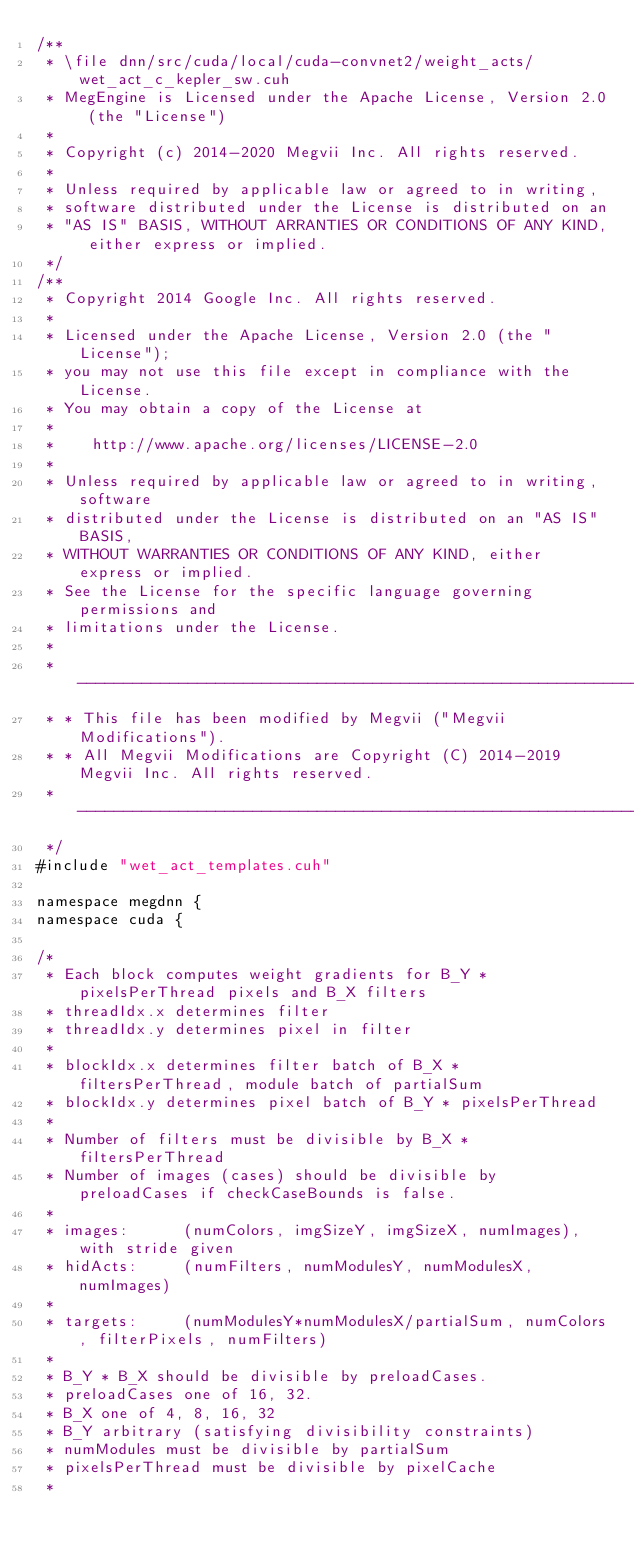Convert code to text. <code><loc_0><loc_0><loc_500><loc_500><_Cuda_>/**
 * \file dnn/src/cuda/local/cuda-convnet2/weight_acts/wet_act_c_kepler_sw.cuh
 * MegEngine is Licensed under the Apache License, Version 2.0 (the "License")
 *
 * Copyright (c) 2014-2020 Megvii Inc. All rights reserved.
 *
 * Unless required by applicable law or agreed to in writing,
 * software distributed under the License is distributed on an
 * "AS IS" BASIS, WITHOUT ARRANTIES OR CONDITIONS OF ANY KIND, either express or implied.
 */
/**
 * Copyright 2014 Google Inc. All rights reserved.
 *
 * Licensed under the Apache License, Version 2.0 (the "License");
 * you may not use this file except in compliance with the License.
 * You may obtain a copy of the License at
 *
 *    http://www.apache.org/licenses/LICENSE-2.0
 *
 * Unless required by applicable law or agreed to in writing, software
 * distributed under the License is distributed on an "AS IS" BASIS,
 * WITHOUT WARRANTIES OR CONDITIONS OF ANY KIND, either express or implied.
 * See the License for the specific language governing permissions and
 * limitations under the License.
 *
 * --------------------------------------------------------------------------
 * * This file has been modified by Megvii ("Megvii Modifications").
 * * All Megvii Modifications are Copyright (C) 2014-2019 Megvii Inc. All rights reserved.
 * --------------------------------------------------------------------------
 */
#include "wet_act_templates.cuh"

namespace megdnn {
namespace cuda {

/*
 * Each block computes weight gradients for B_Y * pixelsPerThread pixels and B_X filters
 * threadIdx.x determines filter
 * threadIdx.y determines pixel in filter
 *
 * blockIdx.x determines filter batch of B_X * filtersPerThread, module batch of partialSum
 * blockIdx.y determines pixel batch of B_Y * pixelsPerThread
 *
 * Number of filters must be divisible by B_X * filtersPerThread
 * Number of images (cases) should be divisible by preloadCases if checkCaseBounds is false.
 *
 * images:      (numColors, imgSizeY, imgSizeX, numImages), with stride given
 * hidActs:     (numFilters, numModulesY, numModulesX, numImages)
 *
 * targets:     (numModulesY*numModulesX/partialSum, numColors, filterPixels, numFilters)
 *
 * B_Y * B_X should be divisible by preloadCases.
 * preloadCases one of 16, 32.
 * B_X one of 4, 8, 16, 32
 * B_Y arbitrary (satisfying divisibility constraints)
 * numModules must be divisible by partialSum
 * pixelsPerThread must be divisible by pixelCache
 *</code> 